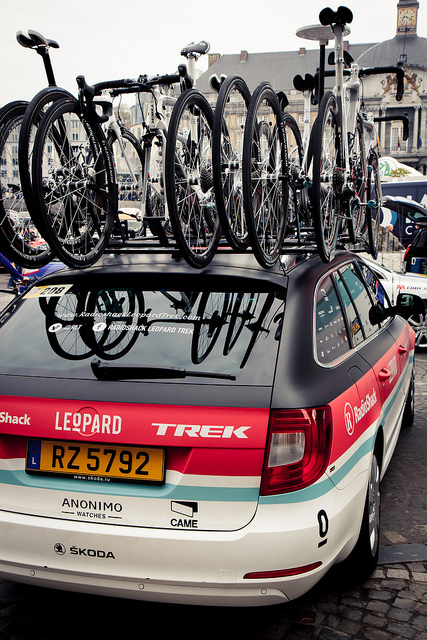Please transcribe the text information in this image. TREK LEOPARD RZ 5792 SKODA CAME RadioShack R WATCHES ANONIMO SHACK 208 TREAT LEOPARD 